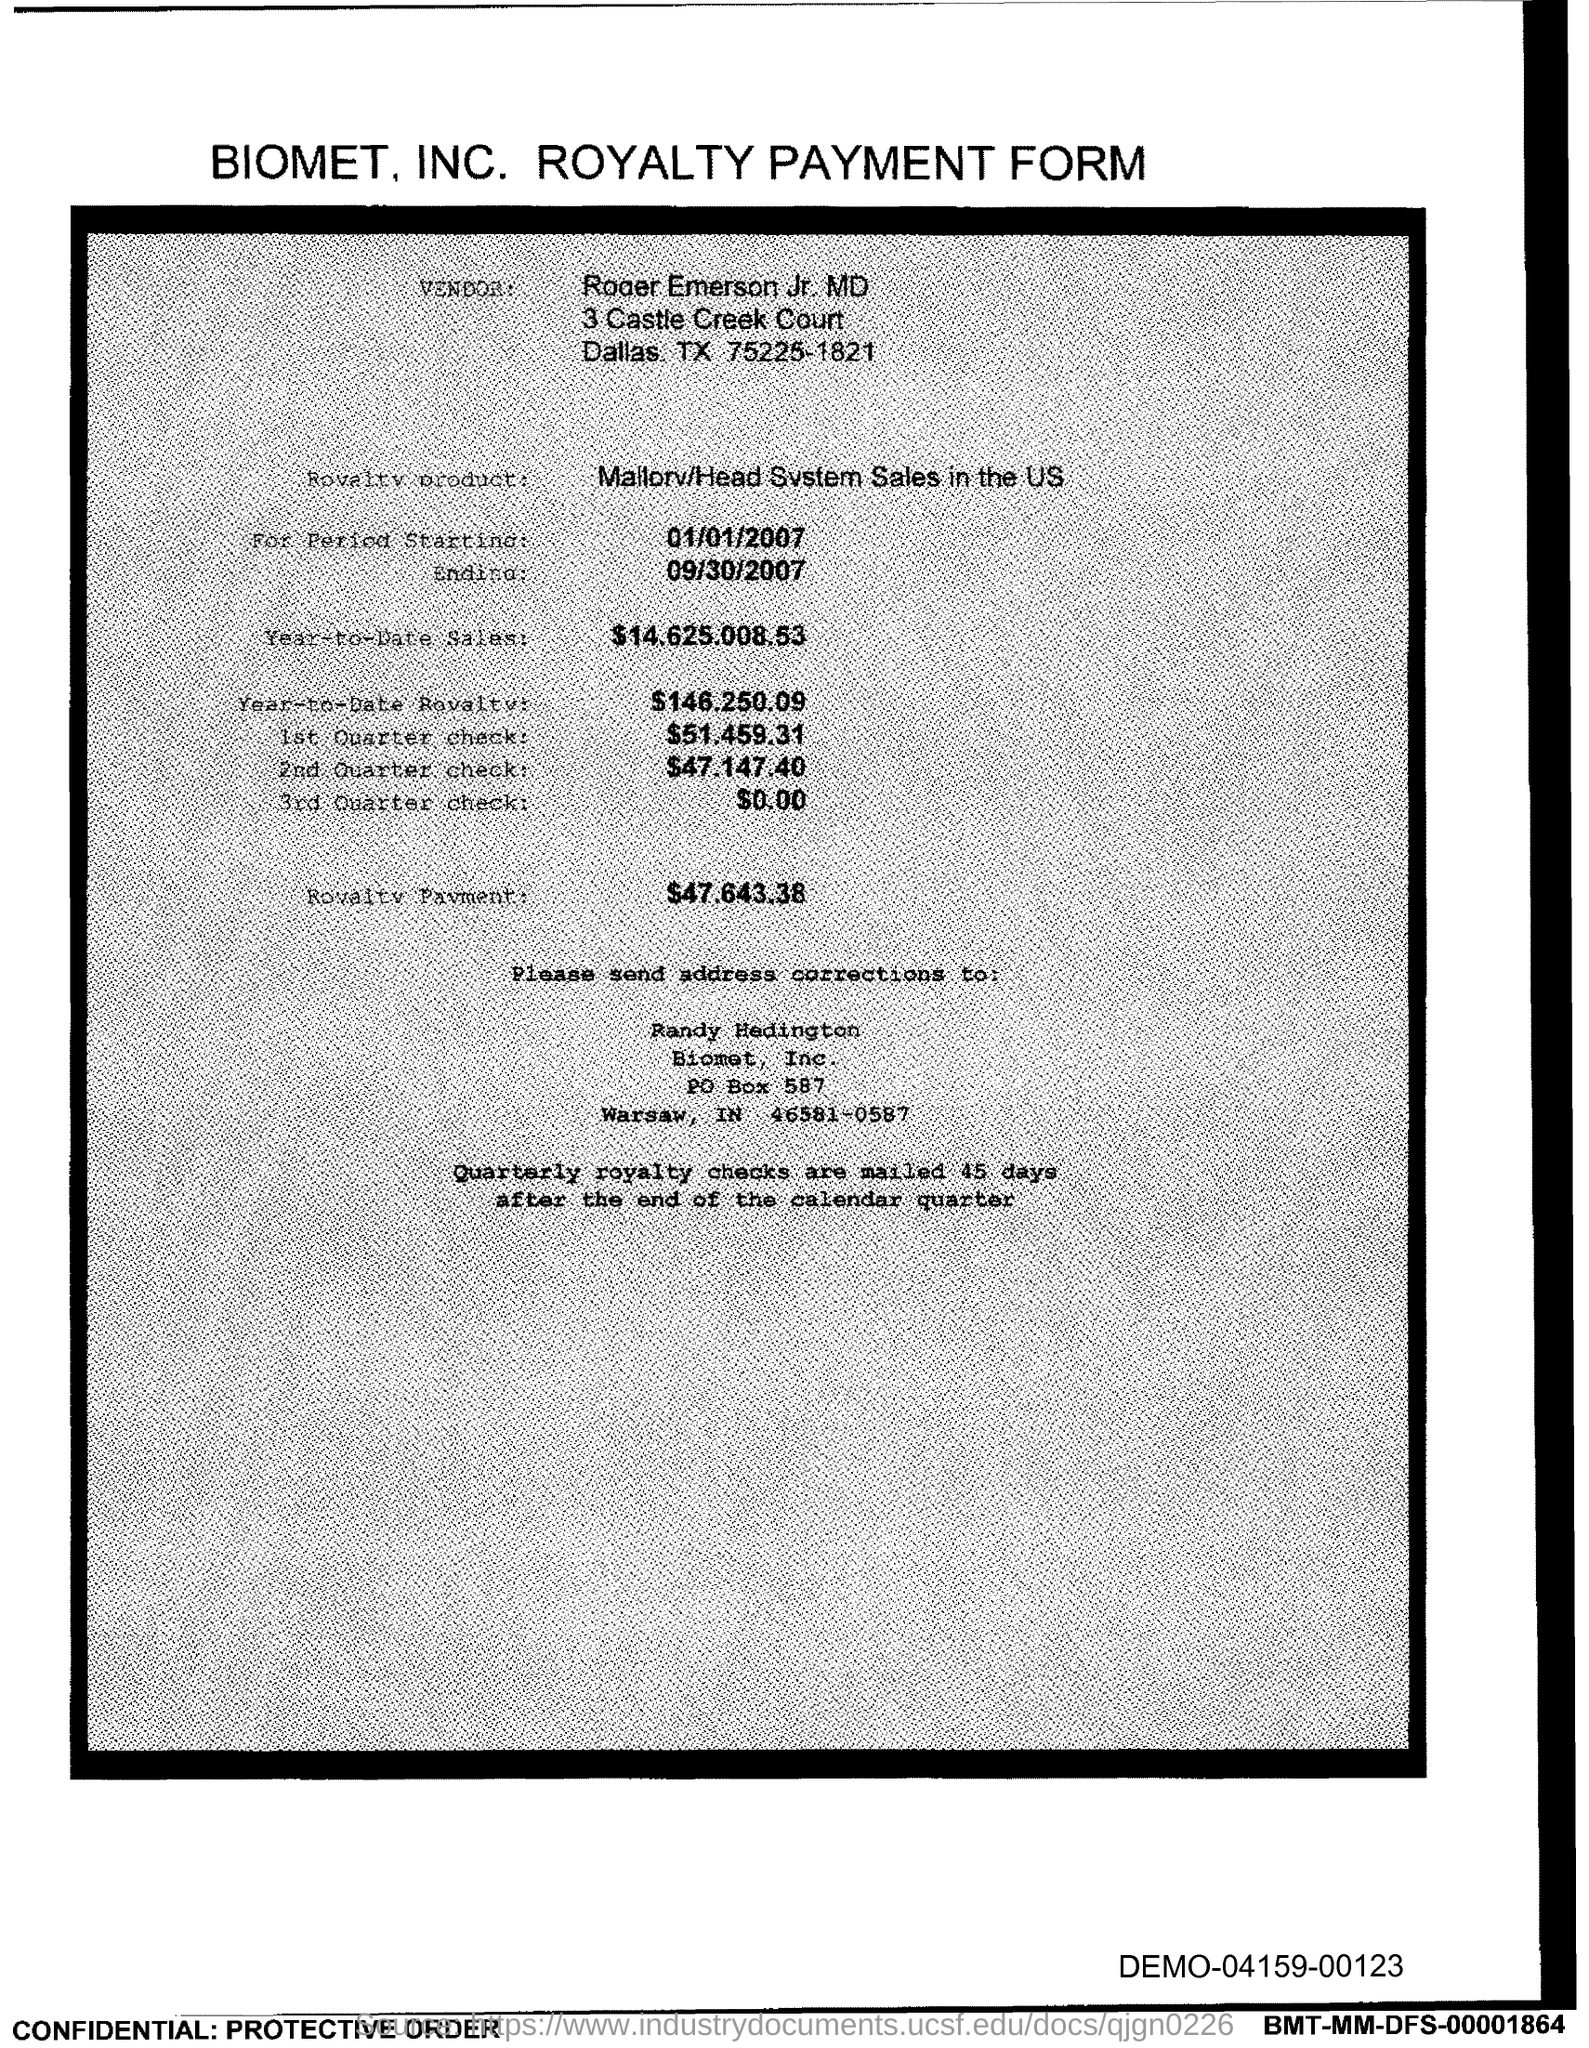Who is the vendor mentioned in the form?
Provide a succinct answer. Roger emerson jr. What is the start date of the royalty period?
Offer a very short reply. 01/01/2007. What is the Year-to-Date Sales of the royalty product?
Your response must be concise. 14,625,008.53. What is the Year-to-Date royalty of the product?
Your answer should be very brief. $146,250.09. What is the amount of 1st quarter check mentioned in the form?
Your answer should be compact. $51,459.31. What is the amount of 3rd Quarter check given in the form?
Your response must be concise. 0.00. What is the royalty payment of the product mentioned in the form?
Make the answer very short. $47,643.38. What is the end date of the royalty period?
Provide a short and direct response. 09/30/2007. 